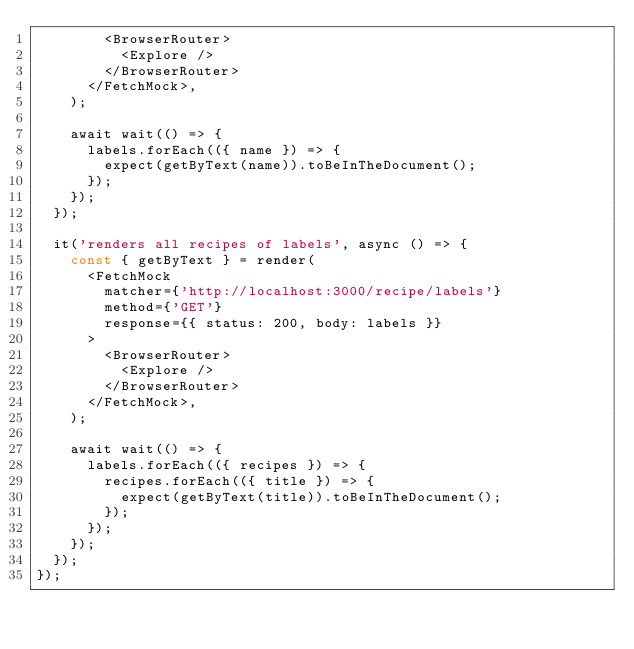Convert code to text. <code><loc_0><loc_0><loc_500><loc_500><_JavaScript_>        <BrowserRouter>
          <Explore />
        </BrowserRouter>
      </FetchMock>,
    );

    await wait(() => {
      labels.forEach(({ name }) => {
        expect(getByText(name)).toBeInTheDocument();
      });
    });
  });

  it('renders all recipes of labels', async () => {
    const { getByText } = render(
      <FetchMock
        matcher={'http://localhost:3000/recipe/labels'}
        method={'GET'}
        response={{ status: 200, body: labels }}
      >
        <BrowserRouter>
          <Explore />
        </BrowserRouter>
      </FetchMock>,
    );

    await wait(() => {
      labels.forEach(({ recipes }) => {
        recipes.forEach(({ title }) => {
          expect(getByText(title)).toBeInTheDocument();
        });
      });
    });
  });
});
</code> 